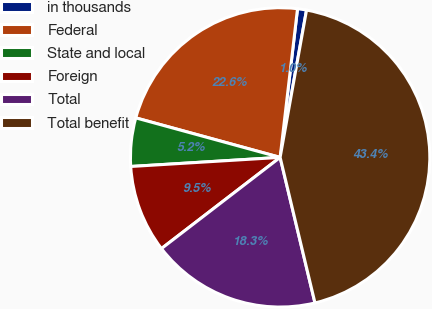Convert chart. <chart><loc_0><loc_0><loc_500><loc_500><pie_chart><fcel>in thousands<fcel>Federal<fcel>State and local<fcel>Foreign<fcel>Total<fcel>Total benefit<nl><fcel>0.97%<fcel>22.6%<fcel>5.22%<fcel>9.46%<fcel>18.31%<fcel>43.43%<nl></chart> 